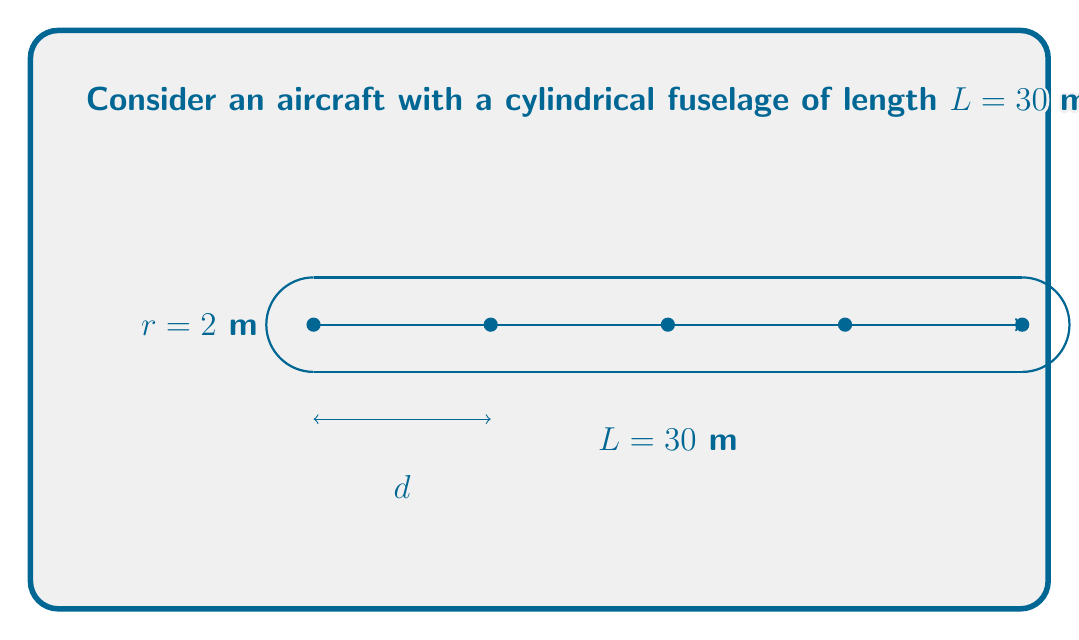Give your solution to this math problem. Let's approach this step-by-step:

1) First, we need to understand that to maximize the minimum distance between sensors, we should place them equidistantly along the fuselage.

2) We have $n=5$ sensors, which means there will be $n-1=4$ equal spaces between them.

3) Let's call the distance between adjacent sensors $d$. We can set up an equation:

   $$(n-1)d = L$$

4) Substituting the known values:

   $$4d = 30$$

5) Solving for $d$:

   $$d = \frac{30}{4} = 7.5$$

6) To verify, let's check the sensor positions:
   - Sensor 1: 0 m
   - Sensor 2: 7.5 m
   - Sensor 3: 15 m
   - Sensor 4: 22.5 m
   - Sensor 5: 30 m

   This indeed covers the entire length of the fuselage with equal spacing.

7) Therefore, the optimal distance between adjacent sensors is 7.5 meters.
Answer: 7.5 meters 